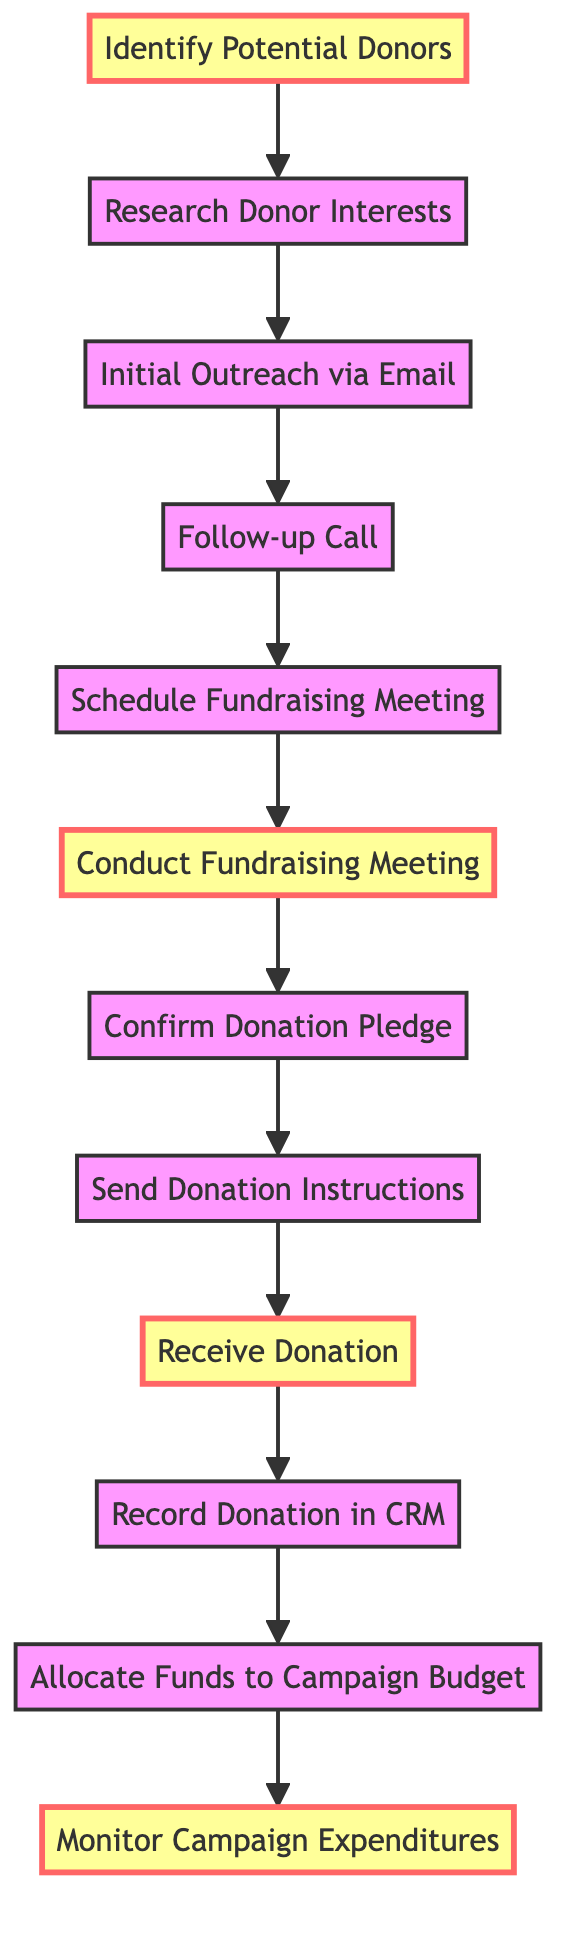What is the first step in the fundraising process? The first node in the diagram is "Identify Potential Donors," which means this is the starting point of the fundraising process.
Answer: Identify Potential Donors How many steps are there in the fundraising process? By counting the nodes in the diagram, there are a total of 12 steps listed, which indicates the number of unique nodes present in the graph.
Answer: 12 What is the relationship between "Initial Outreach via Email" and "Follow-up Call"? The arrow from "Initial Outreach via Email" to "Follow-up Call" shows a direct connection, indicating that the follow-up call comes after the initial outreach step is completed.
Answer: Follow-up Call Which step immediately follows "Conduct Fundraising Meeting"? The directed edge from "Conduct Fundraising Meeting" points to "Confirm Donation Pledge," indicating that this step happens directly after the fundraising meeting.
Answer: Confirm Donation Pledge What is the last step in the fundraising process? The last node in the diagram is "Monitor Campaign Expenditures," which signifies it is the final activity in the sequence of fundraising processes.
Answer: Monitor Campaign Expenditures How many edges are there in the diagram? Each connection between nodes is represented as an edge. There are 11 edges connecting the 12 nodes, indicating there are 11 directed relationships in the process.
Answer: 11 What is the significance of the node "Record Donation in CRM"? This step is crucial because it follows the receipt of the donation and ensures documentation and tracking of the funds for future reference.
Answer: Documentation Which steps are marked as important in the diagram? The nodes identified as important include "Identify Potential Donors," "Conduct Fundraising Meeting," "Receive Donation," and "Monitor Campaign Expenditures," which are highlighted differently in the visual representation.
Answer: Identify Potential Donors, Conduct Fundraising Meeting, Receive Donation, Monitor Campaign Expenditures 